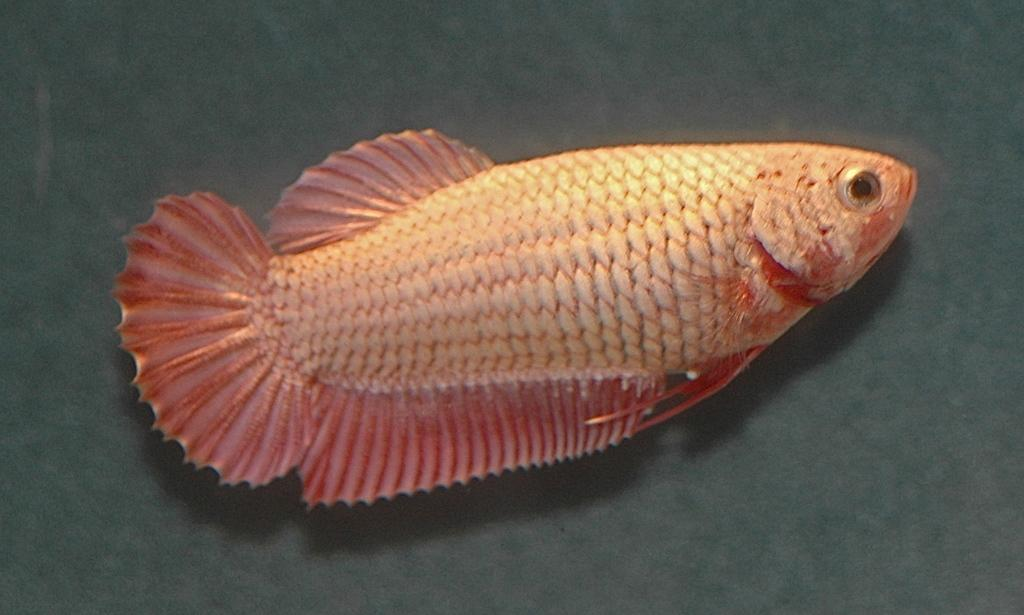What type of animal is in the image? There is a fish in the image. Can you describe the color of the fish? The fish has a pink and cream color. What type of tin can be seen in the image? There is no tin present in the image; it features a fish with a pink and cream color. What type of animal is flying in the image? There is no animal flying in the image; it features a fish. 